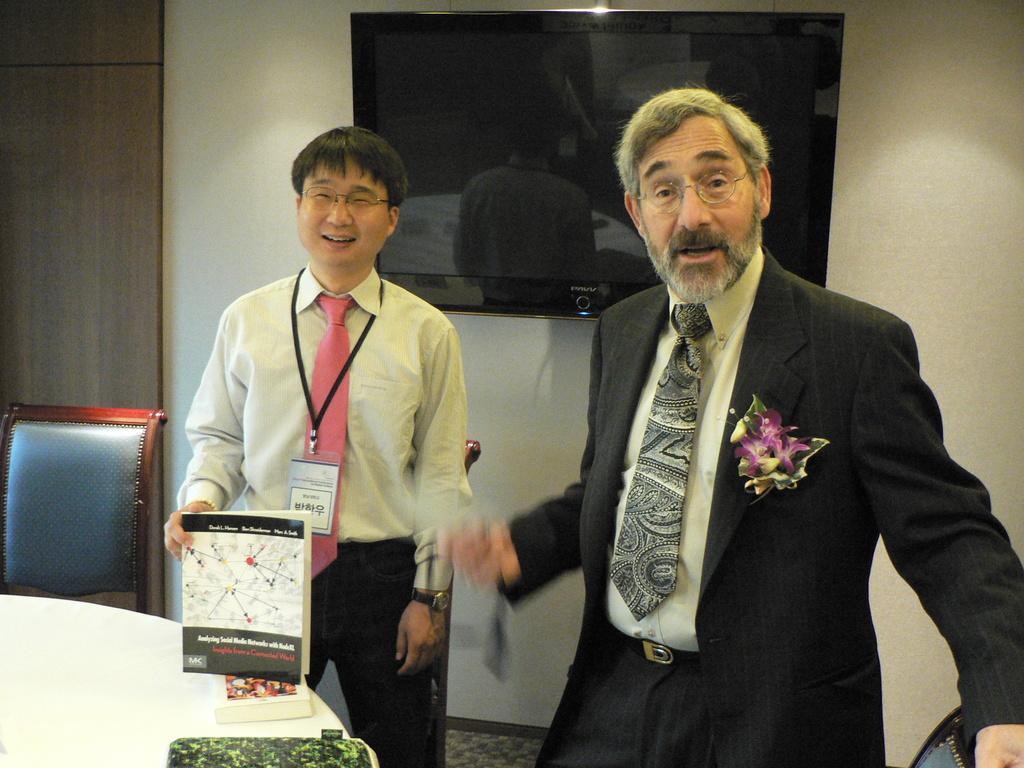Can you describe this image briefly? This image is taken indoors. In the background there is a wall and there is a television. On the left side of the image there is an empty chair and a table with a few books on it. In the middle of the image a man is standing and he is holding a book in his hand and there is a chair. On the right side of the image a man is standing. 